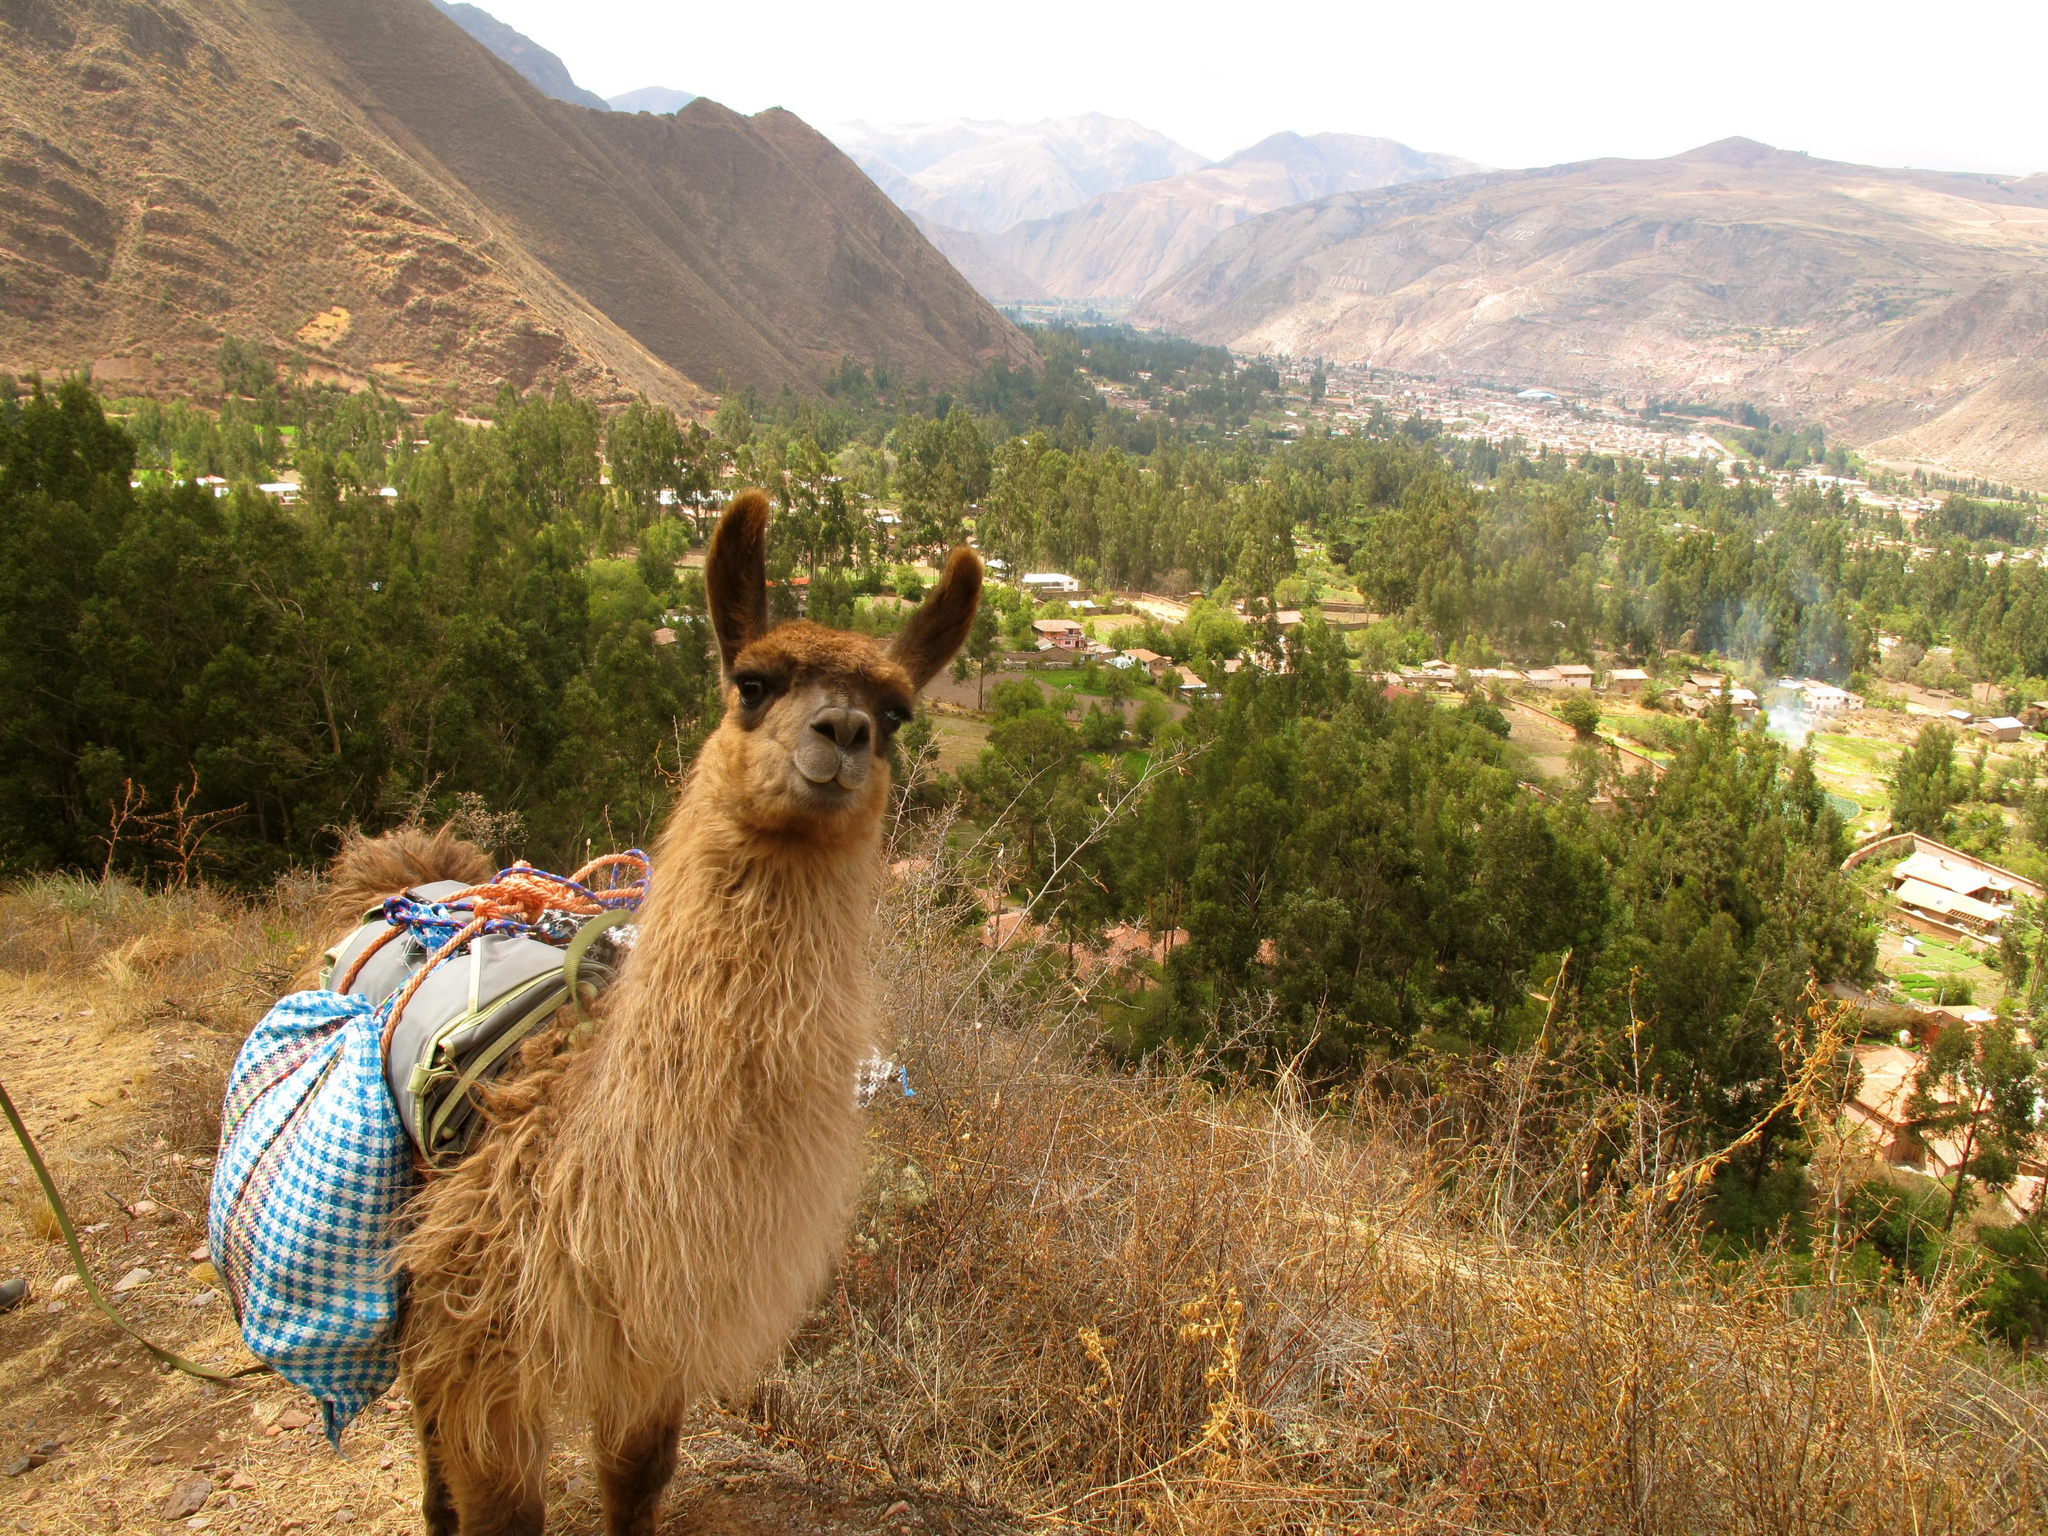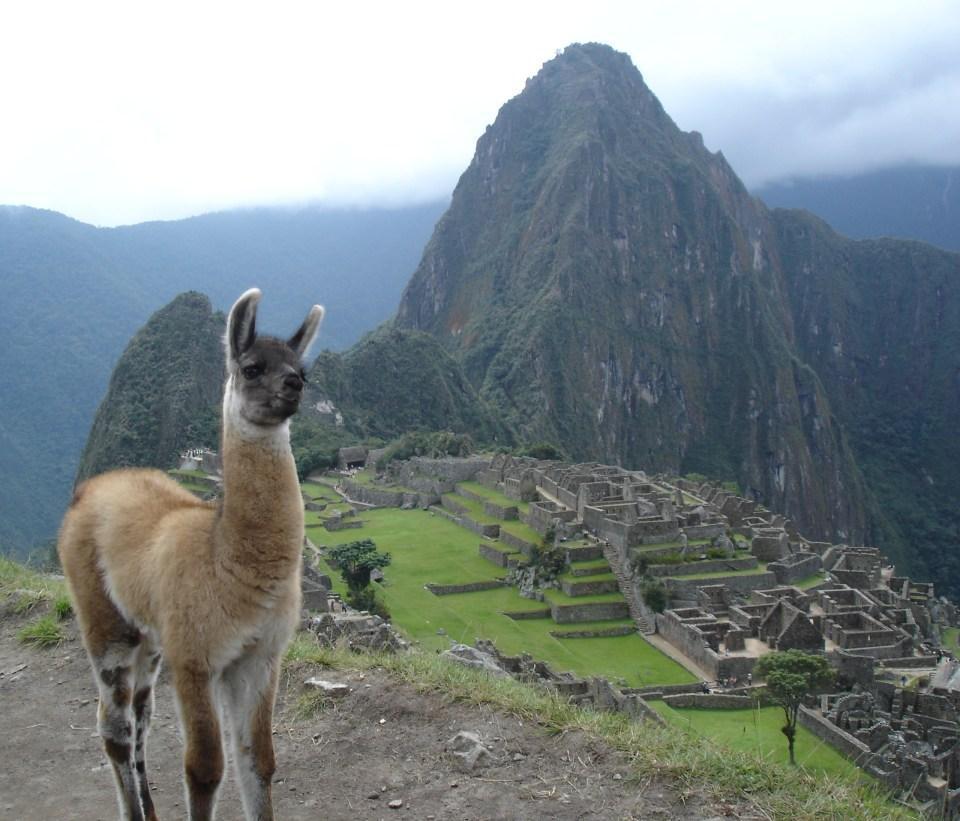The first image is the image on the left, the second image is the image on the right. Examine the images to the left and right. Is the description "At least three animals are on the mountain together in each picture." accurate? Answer yes or no. No. The first image is the image on the left, the second image is the image on the right. Considering the images on both sides, is "In one image, a single llama without a pack is standing on a cliff edge overlooking scenery with mountains in the background." valid? Answer yes or no. Yes. 